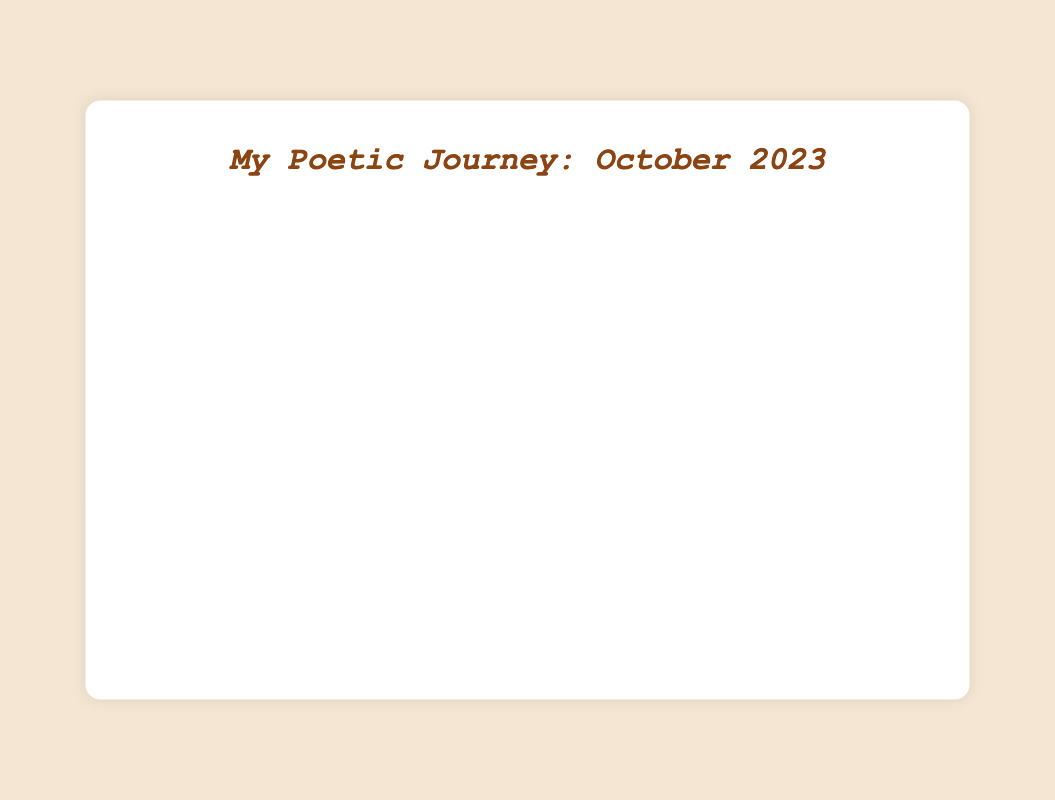Which date had the highest number of poems written? Based on the line chart, the highest number of poems written in a single day was four, which occurred on October 11 and October 22.
Answer: October 11, October 22 Compare the number of poems written on October 11 and October 3. On the line chart, October 11 shows four poems written, while October 3 shows three poems written. Therefore, October 11 had one more poem written than October 3.
Answer: October 11 had one more poem than October 3 What is the average number of poems written per day over the entire month? To find the average, sum all the poems written each day, which totals 57, then divide by 31 days. 57/31 ≈ 1.84.
Answer: 1.84 How many days in October had zero poems written? By counting the points that touch the x-axis on the line chart, it shows zero poems written on October 7, October 14, October 21, and October 28. There are four such days.
Answer: 4 What is the total number of poems written about nature? The data lists poems related to nature on October 1 (2), October 8 (3), October 13 (2), October 20 (2), and October 29 (3). Summing these, 2 + 3 + 2 + 2 + 3 = 12.
Answer: 12 On which date did the number of poems peak sharply, indicating a significant spike? The line chart shows a clear peak at October 11, which jumps from one poem on October 10 to four poems on October 11.
Answer: October 11 What's the total number of poems written in the first week of October? Summing all poems from October 1 to October 7: 2 + 1 + 3 + 2 + 1 + 2 + 0 = 11.
Answer: 11 Compare the total poems written in the first half of the month (October 1-15) with the second half (October 16-31). First, sum poems written from October 1-15: 2+1+3+2+1+2+0+3+2+1+4+1+2+0+3 = 27. Then, sum from October 16-31: 2+1+2+3+2+0+4+2+1+3+1+2+0+3+2+2 = 30. The second half had three more poems written.
Answer: First half: 27, Second half: 30 What is the difference in the number of poems written between the day with the highest productivity and the day with the lowest productivity? The highest productivity is four poems (on October 11 and 22), and the lowest is zero poems (multiple days). The difference is 4 - 0 = 4.
Answer: 4 